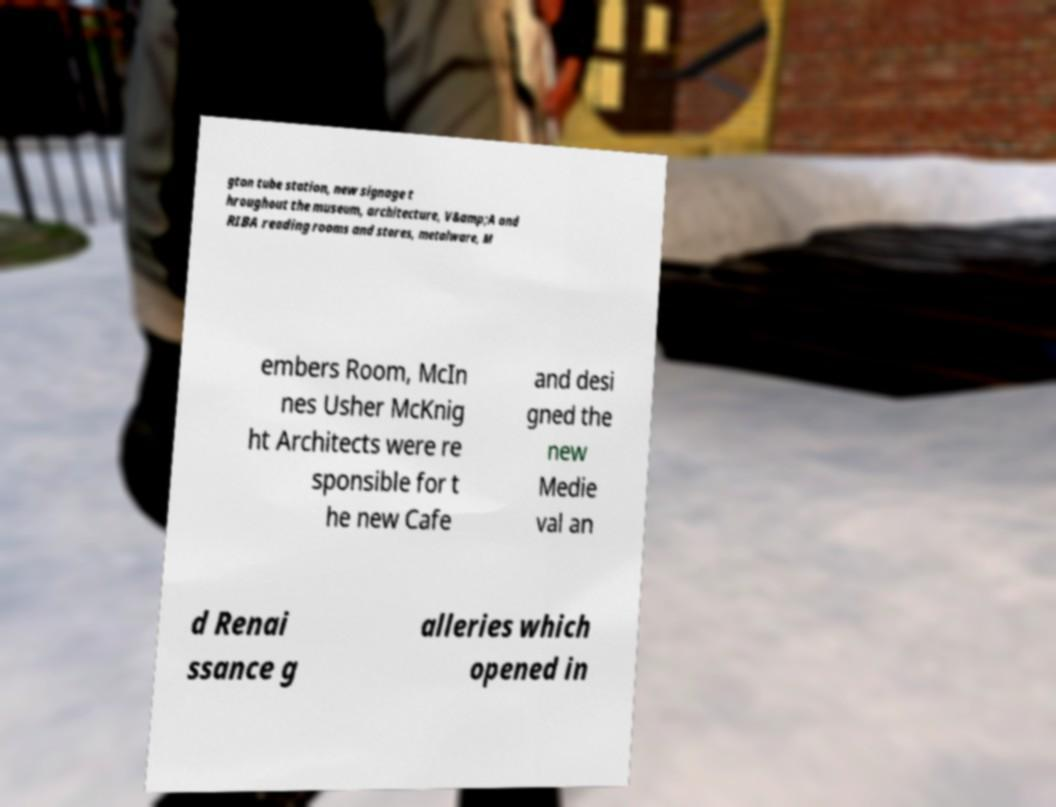Could you assist in decoding the text presented in this image and type it out clearly? gton tube station, new signage t hroughout the museum, architecture, V&amp;A and RIBA reading rooms and stores, metalware, M embers Room, McIn nes Usher McKnig ht Architects were re sponsible for t he new Cafe and desi gned the new Medie val an d Renai ssance g alleries which opened in 